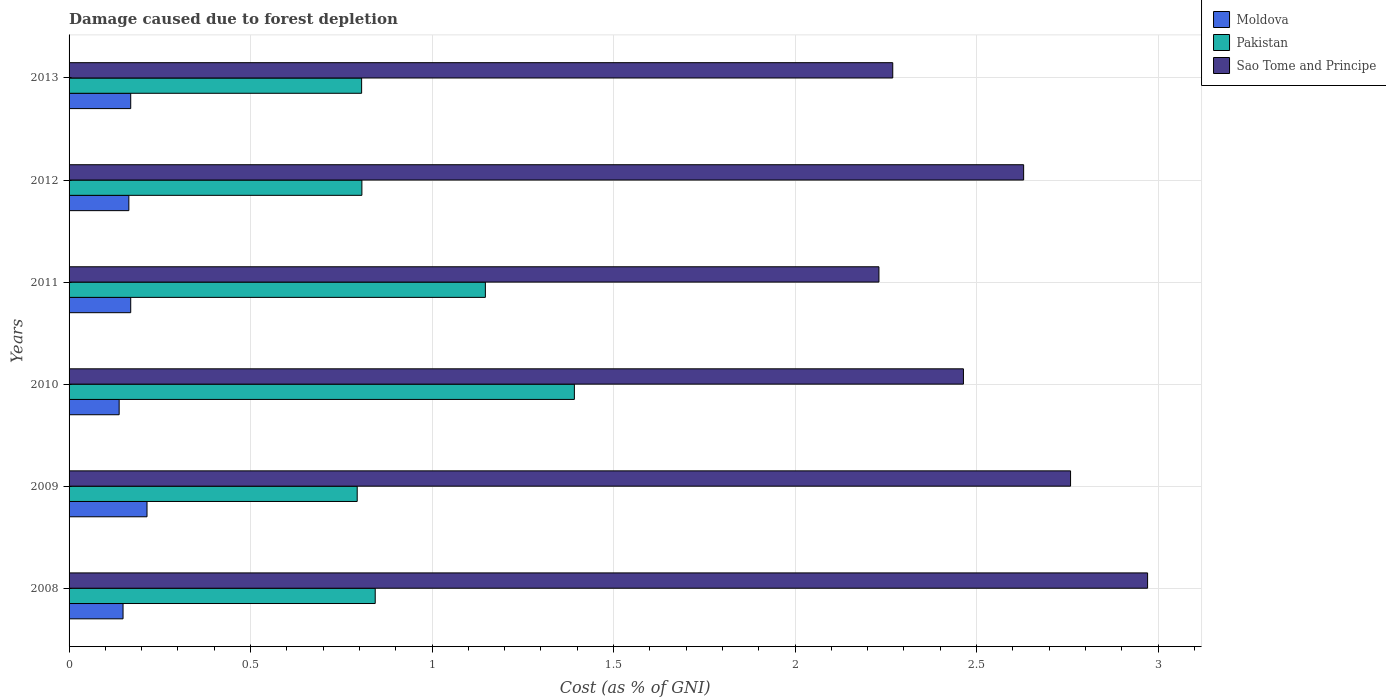How many different coloured bars are there?
Make the answer very short. 3. Are the number of bars on each tick of the Y-axis equal?
Offer a terse response. Yes. How many bars are there on the 4th tick from the top?
Offer a very short reply. 3. How many bars are there on the 4th tick from the bottom?
Offer a terse response. 3. In how many cases, is the number of bars for a given year not equal to the number of legend labels?
Your response must be concise. 0. What is the cost of damage caused due to forest depletion in Sao Tome and Principe in 2013?
Provide a short and direct response. 2.27. Across all years, what is the maximum cost of damage caused due to forest depletion in Pakistan?
Provide a succinct answer. 1.39. Across all years, what is the minimum cost of damage caused due to forest depletion in Sao Tome and Principe?
Your response must be concise. 2.23. What is the total cost of damage caused due to forest depletion in Moldova in the graph?
Ensure brevity in your answer.  1.01. What is the difference between the cost of damage caused due to forest depletion in Sao Tome and Principe in 2010 and that in 2011?
Make the answer very short. 0.23. What is the difference between the cost of damage caused due to forest depletion in Sao Tome and Principe in 2011 and the cost of damage caused due to forest depletion in Pakistan in 2013?
Give a very brief answer. 1.43. What is the average cost of damage caused due to forest depletion in Pakistan per year?
Provide a succinct answer. 0.96. In the year 2008, what is the difference between the cost of damage caused due to forest depletion in Moldova and cost of damage caused due to forest depletion in Pakistan?
Keep it short and to the point. -0.69. In how many years, is the cost of damage caused due to forest depletion in Sao Tome and Principe greater than 0.2 %?
Your answer should be compact. 6. What is the ratio of the cost of damage caused due to forest depletion in Sao Tome and Principe in 2012 to that in 2013?
Provide a succinct answer. 1.16. Is the cost of damage caused due to forest depletion in Sao Tome and Principe in 2008 less than that in 2010?
Ensure brevity in your answer.  No. What is the difference between the highest and the second highest cost of damage caused due to forest depletion in Moldova?
Your response must be concise. 0.04. What is the difference between the highest and the lowest cost of damage caused due to forest depletion in Sao Tome and Principe?
Offer a terse response. 0.74. Is the sum of the cost of damage caused due to forest depletion in Pakistan in 2009 and 2012 greater than the maximum cost of damage caused due to forest depletion in Moldova across all years?
Your answer should be very brief. Yes. What does the 1st bar from the bottom in 2013 represents?
Your response must be concise. Moldova. Is it the case that in every year, the sum of the cost of damage caused due to forest depletion in Moldova and cost of damage caused due to forest depletion in Pakistan is greater than the cost of damage caused due to forest depletion in Sao Tome and Principe?
Ensure brevity in your answer.  No. How many bars are there?
Provide a short and direct response. 18. What is the difference between two consecutive major ticks on the X-axis?
Your answer should be compact. 0.5. Does the graph contain any zero values?
Provide a succinct answer. No. Does the graph contain grids?
Keep it short and to the point. Yes. What is the title of the graph?
Give a very brief answer. Damage caused due to forest depletion. What is the label or title of the X-axis?
Give a very brief answer. Cost (as % of GNI). What is the Cost (as % of GNI) in Moldova in 2008?
Ensure brevity in your answer.  0.15. What is the Cost (as % of GNI) of Pakistan in 2008?
Provide a succinct answer. 0.84. What is the Cost (as % of GNI) in Sao Tome and Principe in 2008?
Provide a succinct answer. 2.97. What is the Cost (as % of GNI) in Moldova in 2009?
Ensure brevity in your answer.  0.21. What is the Cost (as % of GNI) of Pakistan in 2009?
Your answer should be compact. 0.79. What is the Cost (as % of GNI) in Sao Tome and Principe in 2009?
Make the answer very short. 2.76. What is the Cost (as % of GNI) in Moldova in 2010?
Give a very brief answer. 0.14. What is the Cost (as % of GNI) of Pakistan in 2010?
Provide a short and direct response. 1.39. What is the Cost (as % of GNI) of Sao Tome and Principe in 2010?
Offer a very short reply. 2.46. What is the Cost (as % of GNI) of Moldova in 2011?
Offer a very short reply. 0.17. What is the Cost (as % of GNI) of Pakistan in 2011?
Make the answer very short. 1.15. What is the Cost (as % of GNI) in Sao Tome and Principe in 2011?
Offer a very short reply. 2.23. What is the Cost (as % of GNI) of Moldova in 2012?
Ensure brevity in your answer.  0.16. What is the Cost (as % of GNI) in Pakistan in 2012?
Provide a short and direct response. 0.81. What is the Cost (as % of GNI) in Sao Tome and Principe in 2012?
Your answer should be very brief. 2.63. What is the Cost (as % of GNI) in Moldova in 2013?
Make the answer very short. 0.17. What is the Cost (as % of GNI) of Pakistan in 2013?
Keep it short and to the point. 0.81. What is the Cost (as % of GNI) in Sao Tome and Principe in 2013?
Offer a very short reply. 2.27. Across all years, what is the maximum Cost (as % of GNI) of Moldova?
Give a very brief answer. 0.21. Across all years, what is the maximum Cost (as % of GNI) in Pakistan?
Provide a succinct answer. 1.39. Across all years, what is the maximum Cost (as % of GNI) of Sao Tome and Principe?
Your response must be concise. 2.97. Across all years, what is the minimum Cost (as % of GNI) in Moldova?
Give a very brief answer. 0.14. Across all years, what is the minimum Cost (as % of GNI) of Pakistan?
Offer a very short reply. 0.79. Across all years, what is the minimum Cost (as % of GNI) in Sao Tome and Principe?
Make the answer very short. 2.23. What is the total Cost (as % of GNI) in Pakistan in the graph?
Offer a very short reply. 5.79. What is the total Cost (as % of GNI) in Sao Tome and Principe in the graph?
Your answer should be very brief. 15.32. What is the difference between the Cost (as % of GNI) of Moldova in 2008 and that in 2009?
Your answer should be very brief. -0.07. What is the difference between the Cost (as % of GNI) in Pakistan in 2008 and that in 2009?
Keep it short and to the point. 0.05. What is the difference between the Cost (as % of GNI) in Sao Tome and Principe in 2008 and that in 2009?
Your answer should be very brief. 0.21. What is the difference between the Cost (as % of GNI) in Moldova in 2008 and that in 2010?
Give a very brief answer. 0.01. What is the difference between the Cost (as % of GNI) in Pakistan in 2008 and that in 2010?
Ensure brevity in your answer.  -0.55. What is the difference between the Cost (as % of GNI) of Sao Tome and Principe in 2008 and that in 2010?
Your response must be concise. 0.51. What is the difference between the Cost (as % of GNI) of Moldova in 2008 and that in 2011?
Ensure brevity in your answer.  -0.02. What is the difference between the Cost (as % of GNI) in Pakistan in 2008 and that in 2011?
Keep it short and to the point. -0.3. What is the difference between the Cost (as % of GNI) in Sao Tome and Principe in 2008 and that in 2011?
Give a very brief answer. 0.74. What is the difference between the Cost (as % of GNI) of Moldova in 2008 and that in 2012?
Make the answer very short. -0.02. What is the difference between the Cost (as % of GNI) of Pakistan in 2008 and that in 2012?
Provide a short and direct response. 0.04. What is the difference between the Cost (as % of GNI) of Sao Tome and Principe in 2008 and that in 2012?
Offer a terse response. 0.34. What is the difference between the Cost (as % of GNI) of Moldova in 2008 and that in 2013?
Your response must be concise. -0.02. What is the difference between the Cost (as % of GNI) in Pakistan in 2008 and that in 2013?
Offer a terse response. 0.04. What is the difference between the Cost (as % of GNI) of Sao Tome and Principe in 2008 and that in 2013?
Your response must be concise. 0.7. What is the difference between the Cost (as % of GNI) in Moldova in 2009 and that in 2010?
Ensure brevity in your answer.  0.08. What is the difference between the Cost (as % of GNI) of Pakistan in 2009 and that in 2010?
Your answer should be compact. -0.6. What is the difference between the Cost (as % of GNI) of Sao Tome and Principe in 2009 and that in 2010?
Keep it short and to the point. 0.3. What is the difference between the Cost (as % of GNI) of Moldova in 2009 and that in 2011?
Offer a terse response. 0.04. What is the difference between the Cost (as % of GNI) of Pakistan in 2009 and that in 2011?
Make the answer very short. -0.35. What is the difference between the Cost (as % of GNI) of Sao Tome and Principe in 2009 and that in 2011?
Ensure brevity in your answer.  0.53. What is the difference between the Cost (as % of GNI) in Pakistan in 2009 and that in 2012?
Provide a short and direct response. -0.01. What is the difference between the Cost (as % of GNI) in Sao Tome and Principe in 2009 and that in 2012?
Offer a very short reply. 0.13. What is the difference between the Cost (as % of GNI) in Moldova in 2009 and that in 2013?
Your answer should be very brief. 0.04. What is the difference between the Cost (as % of GNI) in Pakistan in 2009 and that in 2013?
Offer a terse response. -0.01. What is the difference between the Cost (as % of GNI) of Sao Tome and Principe in 2009 and that in 2013?
Your answer should be compact. 0.49. What is the difference between the Cost (as % of GNI) of Moldova in 2010 and that in 2011?
Offer a very short reply. -0.03. What is the difference between the Cost (as % of GNI) of Pakistan in 2010 and that in 2011?
Make the answer very short. 0.25. What is the difference between the Cost (as % of GNI) of Sao Tome and Principe in 2010 and that in 2011?
Offer a very short reply. 0.23. What is the difference between the Cost (as % of GNI) of Moldova in 2010 and that in 2012?
Your answer should be compact. -0.03. What is the difference between the Cost (as % of GNI) in Pakistan in 2010 and that in 2012?
Ensure brevity in your answer.  0.59. What is the difference between the Cost (as % of GNI) of Sao Tome and Principe in 2010 and that in 2012?
Give a very brief answer. -0.17. What is the difference between the Cost (as % of GNI) in Moldova in 2010 and that in 2013?
Your response must be concise. -0.03. What is the difference between the Cost (as % of GNI) of Pakistan in 2010 and that in 2013?
Keep it short and to the point. 0.59. What is the difference between the Cost (as % of GNI) of Sao Tome and Principe in 2010 and that in 2013?
Give a very brief answer. 0.19. What is the difference between the Cost (as % of GNI) in Moldova in 2011 and that in 2012?
Offer a very short reply. 0.01. What is the difference between the Cost (as % of GNI) of Pakistan in 2011 and that in 2012?
Offer a very short reply. 0.34. What is the difference between the Cost (as % of GNI) of Sao Tome and Principe in 2011 and that in 2012?
Keep it short and to the point. -0.4. What is the difference between the Cost (as % of GNI) in Moldova in 2011 and that in 2013?
Make the answer very short. 0. What is the difference between the Cost (as % of GNI) in Pakistan in 2011 and that in 2013?
Offer a very short reply. 0.34. What is the difference between the Cost (as % of GNI) in Sao Tome and Principe in 2011 and that in 2013?
Your answer should be very brief. -0.04. What is the difference between the Cost (as % of GNI) of Moldova in 2012 and that in 2013?
Offer a very short reply. -0.01. What is the difference between the Cost (as % of GNI) in Pakistan in 2012 and that in 2013?
Your answer should be very brief. 0. What is the difference between the Cost (as % of GNI) in Sao Tome and Principe in 2012 and that in 2013?
Provide a succinct answer. 0.36. What is the difference between the Cost (as % of GNI) in Moldova in 2008 and the Cost (as % of GNI) in Pakistan in 2009?
Your response must be concise. -0.65. What is the difference between the Cost (as % of GNI) of Moldova in 2008 and the Cost (as % of GNI) of Sao Tome and Principe in 2009?
Ensure brevity in your answer.  -2.61. What is the difference between the Cost (as % of GNI) in Pakistan in 2008 and the Cost (as % of GNI) in Sao Tome and Principe in 2009?
Offer a terse response. -1.92. What is the difference between the Cost (as % of GNI) of Moldova in 2008 and the Cost (as % of GNI) of Pakistan in 2010?
Your answer should be very brief. -1.24. What is the difference between the Cost (as % of GNI) of Moldova in 2008 and the Cost (as % of GNI) of Sao Tome and Principe in 2010?
Give a very brief answer. -2.32. What is the difference between the Cost (as % of GNI) of Pakistan in 2008 and the Cost (as % of GNI) of Sao Tome and Principe in 2010?
Your answer should be compact. -1.62. What is the difference between the Cost (as % of GNI) in Moldova in 2008 and the Cost (as % of GNI) in Pakistan in 2011?
Keep it short and to the point. -1. What is the difference between the Cost (as % of GNI) in Moldova in 2008 and the Cost (as % of GNI) in Sao Tome and Principe in 2011?
Your response must be concise. -2.08. What is the difference between the Cost (as % of GNI) in Pakistan in 2008 and the Cost (as % of GNI) in Sao Tome and Principe in 2011?
Your answer should be very brief. -1.39. What is the difference between the Cost (as % of GNI) of Moldova in 2008 and the Cost (as % of GNI) of Pakistan in 2012?
Your answer should be very brief. -0.66. What is the difference between the Cost (as % of GNI) of Moldova in 2008 and the Cost (as % of GNI) of Sao Tome and Principe in 2012?
Offer a very short reply. -2.48. What is the difference between the Cost (as % of GNI) in Pakistan in 2008 and the Cost (as % of GNI) in Sao Tome and Principe in 2012?
Provide a short and direct response. -1.79. What is the difference between the Cost (as % of GNI) of Moldova in 2008 and the Cost (as % of GNI) of Pakistan in 2013?
Your response must be concise. -0.66. What is the difference between the Cost (as % of GNI) in Moldova in 2008 and the Cost (as % of GNI) in Sao Tome and Principe in 2013?
Offer a very short reply. -2.12. What is the difference between the Cost (as % of GNI) of Pakistan in 2008 and the Cost (as % of GNI) of Sao Tome and Principe in 2013?
Offer a terse response. -1.43. What is the difference between the Cost (as % of GNI) in Moldova in 2009 and the Cost (as % of GNI) in Pakistan in 2010?
Your answer should be compact. -1.18. What is the difference between the Cost (as % of GNI) of Moldova in 2009 and the Cost (as % of GNI) of Sao Tome and Principe in 2010?
Make the answer very short. -2.25. What is the difference between the Cost (as % of GNI) of Pakistan in 2009 and the Cost (as % of GNI) of Sao Tome and Principe in 2010?
Keep it short and to the point. -1.67. What is the difference between the Cost (as % of GNI) in Moldova in 2009 and the Cost (as % of GNI) in Pakistan in 2011?
Your response must be concise. -0.93. What is the difference between the Cost (as % of GNI) in Moldova in 2009 and the Cost (as % of GNI) in Sao Tome and Principe in 2011?
Provide a short and direct response. -2.02. What is the difference between the Cost (as % of GNI) in Pakistan in 2009 and the Cost (as % of GNI) in Sao Tome and Principe in 2011?
Keep it short and to the point. -1.44. What is the difference between the Cost (as % of GNI) of Moldova in 2009 and the Cost (as % of GNI) of Pakistan in 2012?
Your answer should be compact. -0.59. What is the difference between the Cost (as % of GNI) in Moldova in 2009 and the Cost (as % of GNI) in Sao Tome and Principe in 2012?
Your response must be concise. -2.42. What is the difference between the Cost (as % of GNI) in Pakistan in 2009 and the Cost (as % of GNI) in Sao Tome and Principe in 2012?
Keep it short and to the point. -1.84. What is the difference between the Cost (as % of GNI) in Moldova in 2009 and the Cost (as % of GNI) in Pakistan in 2013?
Your response must be concise. -0.59. What is the difference between the Cost (as % of GNI) in Moldova in 2009 and the Cost (as % of GNI) in Sao Tome and Principe in 2013?
Give a very brief answer. -2.05. What is the difference between the Cost (as % of GNI) in Pakistan in 2009 and the Cost (as % of GNI) in Sao Tome and Principe in 2013?
Give a very brief answer. -1.48. What is the difference between the Cost (as % of GNI) in Moldova in 2010 and the Cost (as % of GNI) in Pakistan in 2011?
Offer a terse response. -1.01. What is the difference between the Cost (as % of GNI) of Moldova in 2010 and the Cost (as % of GNI) of Sao Tome and Principe in 2011?
Offer a very short reply. -2.09. What is the difference between the Cost (as % of GNI) of Pakistan in 2010 and the Cost (as % of GNI) of Sao Tome and Principe in 2011?
Your answer should be very brief. -0.84. What is the difference between the Cost (as % of GNI) in Moldova in 2010 and the Cost (as % of GNI) in Pakistan in 2012?
Your response must be concise. -0.67. What is the difference between the Cost (as % of GNI) in Moldova in 2010 and the Cost (as % of GNI) in Sao Tome and Principe in 2012?
Make the answer very short. -2.49. What is the difference between the Cost (as % of GNI) in Pakistan in 2010 and the Cost (as % of GNI) in Sao Tome and Principe in 2012?
Your answer should be very brief. -1.24. What is the difference between the Cost (as % of GNI) of Moldova in 2010 and the Cost (as % of GNI) of Pakistan in 2013?
Offer a terse response. -0.67. What is the difference between the Cost (as % of GNI) of Moldova in 2010 and the Cost (as % of GNI) of Sao Tome and Principe in 2013?
Provide a succinct answer. -2.13. What is the difference between the Cost (as % of GNI) in Pakistan in 2010 and the Cost (as % of GNI) in Sao Tome and Principe in 2013?
Your response must be concise. -0.88. What is the difference between the Cost (as % of GNI) in Moldova in 2011 and the Cost (as % of GNI) in Pakistan in 2012?
Provide a short and direct response. -0.64. What is the difference between the Cost (as % of GNI) of Moldova in 2011 and the Cost (as % of GNI) of Sao Tome and Principe in 2012?
Your answer should be very brief. -2.46. What is the difference between the Cost (as % of GNI) in Pakistan in 2011 and the Cost (as % of GNI) in Sao Tome and Principe in 2012?
Provide a succinct answer. -1.48. What is the difference between the Cost (as % of GNI) of Moldova in 2011 and the Cost (as % of GNI) of Pakistan in 2013?
Keep it short and to the point. -0.64. What is the difference between the Cost (as % of GNI) of Moldova in 2011 and the Cost (as % of GNI) of Sao Tome and Principe in 2013?
Your answer should be very brief. -2.1. What is the difference between the Cost (as % of GNI) in Pakistan in 2011 and the Cost (as % of GNI) in Sao Tome and Principe in 2013?
Your answer should be compact. -1.12. What is the difference between the Cost (as % of GNI) of Moldova in 2012 and the Cost (as % of GNI) of Pakistan in 2013?
Offer a terse response. -0.64. What is the difference between the Cost (as % of GNI) in Moldova in 2012 and the Cost (as % of GNI) in Sao Tome and Principe in 2013?
Offer a terse response. -2.1. What is the difference between the Cost (as % of GNI) of Pakistan in 2012 and the Cost (as % of GNI) of Sao Tome and Principe in 2013?
Your answer should be compact. -1.46. What is the average Cost (as % of GNI) of Moldova per year?
Ensure brevity in your answer.  0.17. What is the average Cost (as % of GNI) in Pakistan per year?
Your answer should be compact. 0.96. What is the average Cost (as % of GNI) of Sao Tome and Principe per year?
Ensure brevity in your answer.  2.55. In the year 2008, what is the difference between the Cost (as % of GNI) of Moldova and Cost (as % of GNI) of Pakistan?
Provide a succinct answer. -0.69. In the year 2008, what is the difference between the Cost (as % of GNI) in Moldova and Cost (as % of GNI) in Sao Tome and Principe?
Offer a terse response. -2.82. In the year 2008, what is the difference between the Cost (as % of GNI) of Pakistan and Cost (as % of GNI) of Sao Tome and Principe?
Offer a very short reply. -2.13. In the year 2009, what is the difference between the Cost (as % of GNI) in Moldova and Cost (as % of GNI) in Pakistan?
Offer a very short reply. -0.58. In the year 2009, what is the difference between the Cost (as % of GNI) of Moldova and Cost (as % of GNI) of Sao Tome and Principe?
Your answer should be very brief. -2.54. In the year 2009, what is the difference between the Cost (as % of GNI) of Pakistan and Cost (as % of GNI) of Sao Tome and Principe?
Offer a very short reply. -1.97. In the year 2010, what is the difference between the Cost (as % of GNI) of Moldova and Cost (as % of GNI) of Pakistan?
Offer a very short reply. -1.25. In the year 2010, what is the difference between the Cost (as % of GNI) in Moldova and Cost (as % of GNI) in Sao Tome and Principe?
Your answer should be compact. -2.33. In the year 2010, what is the difference between the Cost (as % of GNI) of Pakistan and Cost (as % of GNI) of Sao Tome and Principe?
Make the answer very short. -1.07. In the year 2011, what is the difference between the Cost (as % of GNI) in Moldova and Cost (as % of GNI) in Pakistan?
Make the answer very short. -0.98. In the year 2011, what is the difference between the Cost (as % of GNI) in Moldova and Cost (as % of GNI) in Sao Tome and Principe?
Make the answer very short. -2.06. In the year 2011, what is the difference between the Cost (as % of GNI) of Pakistan and Cost (as % of GNI) of Sao Tome and Principe?
Offer a terse response. -1.08. In the year 2012, what is the difference between the Cost (as % of GNI) of Moldova and Cost (as % of GNI) of Pakistan?
Make the answer very short. -0.64. In the year 2012, what is the difference between the Cost (as % of GNI) in Moldova and Cost (as % of GNI) in Sao Tome and Principe?
Offer a terse response. -2.46. In the year 2012, what is the difference between the Cost (as % of GNI) of Pakistan and Cost (as % of GNI) of Sao Tome and Principe?
Your answer should be very brief. -1.82. In the year 2013, what is the difference between the Cost (as % of GNI) of Moldova and Cost (as % of GNI) of Pakistan?
Offer a terse response. -0.64. In the year 2013, what is the difference between the Cost (as % of GNI) of Moldova and Cost (as % of GNI) of Sao Tome and Principe?
Keep it short and to the point. -2.1. In the year 2013, what is the difference between the Cost (as % of GNI) of Pakistan and Cost (as % of GNI) of Sao Tome and Principe?
Offer a terse response. -1.46. What is the ratio of the Cost (as % of GNI) in Moldova in 2008 to that in 2009?
Provide a succinct answer. 0.69. What is the ratio of the Cost (as % of GNI) of Pakistan in 2008 to that in 2009?
Offer a very short reply. 1.06. What is the ratio of the Cost (as % of GNI) in Sao Tome and Principe in 2008 to that in 2009?
Make the answer very short. 1.08. What is the ratio of the Cost (as % of GNI) in Moldova in 2008 to that in 2010?
Provide a short and direct response. 1.08. What is the ratio of the Cost (as % of GNI) of Pakistan in 2008 to that in 2010?
Make the answer very short. 0.61. What is the ratio of the Cost (as % of GNI) of Sao Tome and Principe in 2008 to that in 2010?
Ensure brevity in your answer.  1.21. What is the ratio of the Cost (as % of GNI) in Moldova in 2008 to that in 2011?
Your answer should be very brief. 0.88. What is the ratio of the Cost (as % of GNI) of Pakistan in 2008 to that in 2011?
Your response must be concise. 0.74. What is the ratio of the Cost (as % of GNI) of Sao Tome and Principe in 2008 to that in 2011?
Keep it short and to the point. 1.33. What is the ratio of the Cost (as % of GNI) in Moldova in 2008 to that in 2012?
Your answer should be very brief. 0.9. What is the ratio of the Cost (as % of GNI) of Pakistan in 2008 to that in 2012?
Your answer should be very brief. 1.05. What is the ratio of the Cost (as % of GNI) of Sao Tome and Principe in 2008 to that in 2012?
Provide a short and direct response. 1.13. What is the ratio of the Cost (as % of GNI) in Moldova in 2008 to that in 2013?
Provide a succinct answer. 0.88. What is the ratio of the Cost (as % of GNI) of Pakistan in 2008 to that in 2013?
Offer a very short reply. 1.05. What is the ratio of the Cost (as % of GNI) of Sao Tome and Principe in 2008 to that in 2013?
Offer a very short reply. 1.31. What is the ratio of the Cost (as % of GNI) in Moldova in 2009 to that in 2010?
Your response must be concise. 1.56. What is the ratio of the Cost (as % of GNI) in Pakistan in 2009 to that in 2010?
Keep it short and to the point. 0.57. What is the ratio of the Cost (as % of GNI) in Sao Tome and Principe in 2009 to that in 2010?
Offer a terse response. 1.12. What is the ratio of the Cost (as % of GNI) in Moldova in 2009 to that in 2011?
Offer a very short reply. 1.26. What is the ratio of the Cost (as % of GNI) of Pakistan in 2009 to that in 2011?
Keep it short and to the point. 0.69. What is the ratio of the Cost (as % of GNI) of Sao Tome and Principe in 2009 to that in 2011?
Your answer should be compact. 1.24. What is the ratio of the Cost (as % of GNI) of Moldova in 2009 to that in 2012?
Keep it short and to the point. 1.3. What is the ratio of the Cost (as % of GNI) of Pakistan in 2009 to that in 2012?
Keep it short and to the point. 0.98. What is the ratio of the Cost (as % of GNI) of Sao Tome and Principe in 2009 to that in 2012?
Provide a short and direct response. 1.05. What is the ratio of the Cost (as % of GNI) of Moldova in 2009 to that in 2013?
Make the answer very short. 1.26. What is the ratio of the Cost (as % of GNI) in Pakistan in 2009 to that in 2013?
Make the answer very short. 0.98. What is the ratio of the Cost (as % of GNI) of Sao Tome and Principe in 2009 to that in 2013?
Ensure brevity in your answer.  1.22. What is the ratio of the Cost (as % of GNI) of Moldova in 2010 to that in 2011?
Offer a very short reply. 0.81. What is the ratio of the Cost (as % of GNI) of Pakistan in 2010 to that in 2011?
Keep it short and to the point. 1.21. What is the ratio of the Cost (as % of GNI) in Sao Tome and Principe in 2010 to that in 2011?
Give a very brief answer. 1.1. What is the ratio of the Cost (as % of GNI) in Moldova in 2010 to that in 2012?
Make the answer very short. 0.84. What is the ratio of the Cost (as % of GNI) of Pakistan in 2010 to that in 2012?
Offer a very short reply. 1.73. What is the ratio of the Cost (as % of GNI) of Sao Tome and Principe in 2010 to that in 2012?
Ensure brevity in your answer.  0.94. What is the ratio of the Cost (as % of GNI) of Moldova in 2010 to that in 2013?
Your answer should be very brief. 0.81. What is the ratio of the Cost (as % of GNI) of Pakistan in 2010 to that in 2013?
Make the answer very short. 1.73. What is the ratio of the Cost (as % of GNI) of Sao Tome and Principe in 2010 to that in 2013?
Give a very brief answer. 1.09. What is the ratio of the Cost (as % of GNI) of Moldova in 2011 to that in 2012?
Your answer should be very brief. 1.03. What is the ratio of the Cost (as % of GNI) in Pakistan in 2011 to that in 2012?
Provide a succinct answer. 1.42. What is the ratio of the Cost (as % of GNI) in Sao Tome and Principe in 2011 to that in 2012?
Your answer should be compact. 0.85. What is the ratio of the Cost (as % of GNI) of Moldova in 2011 to that in 2013?
Provide a short and direct response. 1. What is the ratio of the Cost (as % of GNI) in Pakistan in 2011 to that in 2013?
Your answer should be compact. 1.42. What is the ratio of the Cost (as % of GNI) of Sao Tome and Principe in 2011 to that in 2013?
Keep it short and to the point. 0.98. What is the ratio of the Cost (as % of GNI) in Moldova in 2012 to that in 2013?
Offer a terse response. 0.97. What is the ratio of the Cost (as % of GNI) of Pakistan in 2012 to that in 2013?
Make the answer very short. 1. What is the ratio of the Cost (as % of GNI) of Sao Tome and Principe in 2012 to that in 2013?
Ensure brevity in your answer.  1.16. What is the difference between the highest and the second highest Cost (as % of GNI) of Moldova?
Provide a short and direct response. 0.04. What is the difference between the highest and the second highest Cost (as % of GNI) in Pakistan?
Your answer should be compact. 0.25. What is the difference between the highest and the second highest Cost (as % of GNI) in Sao Tome and Principe?
Offer a terse response. 0.21. What is the difference between the highest and the lowest Cost (as % of GNI) in Moldova?
Provide a succinct answer. 0.08. What is the difference between the highest and the lowest Cost (as % of GNI) in Pakistan?
Make the answer very short. 0.6. What is the difference between the highest and the lowest Cost (as % of GNI) of Sao Tome and Principe?
Offer a very short reply. 0.74. 